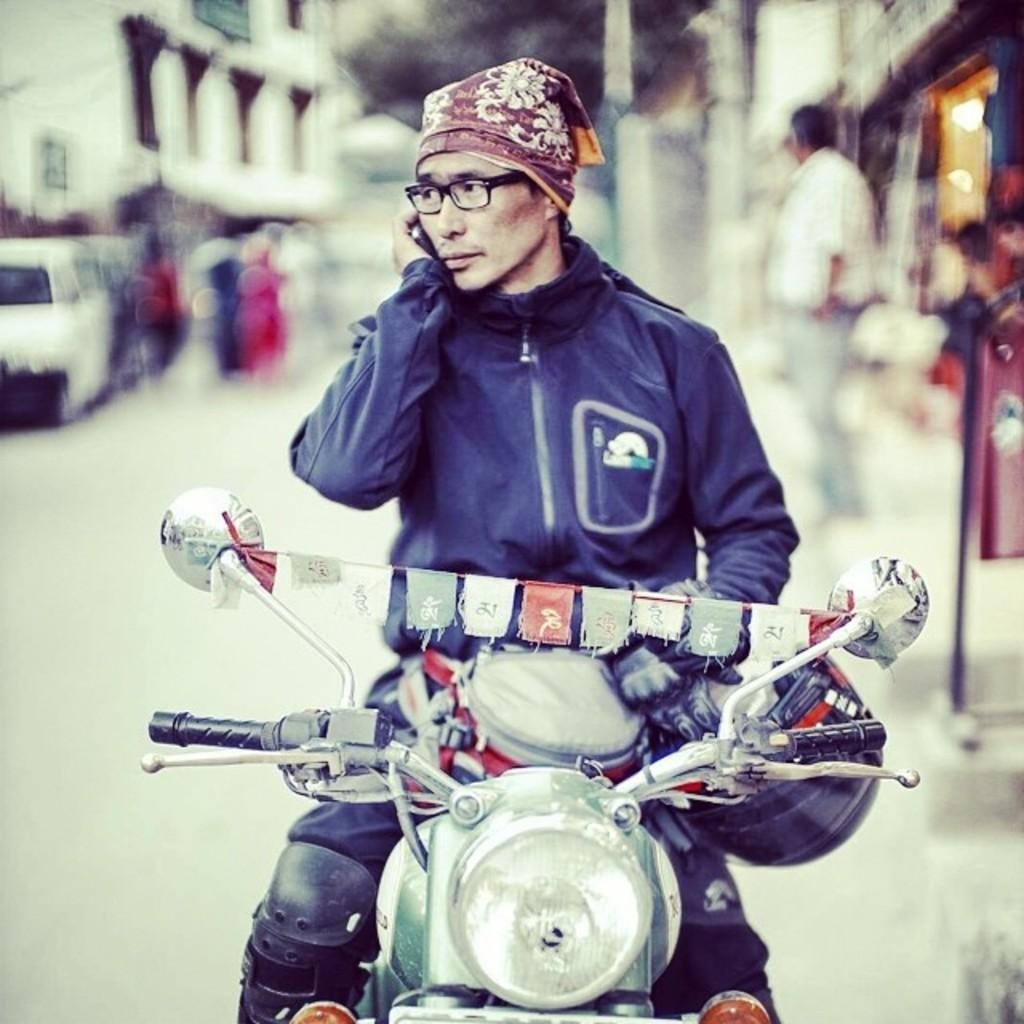What is the man in the image holding? The man is holding a mobile in the image. What is the man doing in the image? The man is sitting on a bike in the image. What can be seen in the background of the image? There is a car, a building, a group of people, and trees in the background of the image. What historical event is the man commemorating in the image? There is no indication of a historical event in the image; the man is simply sitting on a bike holding a mobile. 